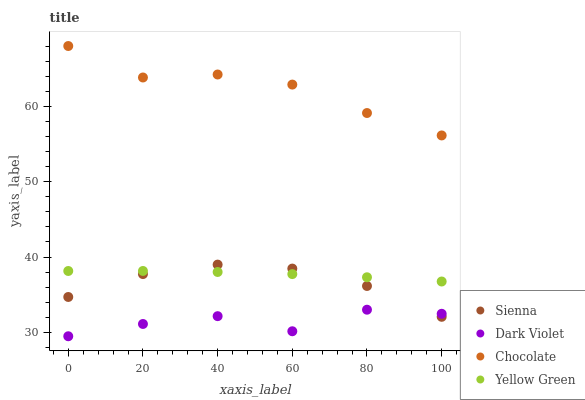Does Dark Violet have the minimum area under the curve?
Answer yes or no. Yes. Does Chocolate have the maximum area under the curve?
Answer yes or no. Yes. Does Yellow Green have the minimum area under the curve?
Answer yes or no. No. Does Yellow Green have the maximum area under the curve?
Answer yes or no. No. Is Yellow Green the smoothest?
Answer yes or no. Yes. Is Dark Violet the roughest?
Answer yes or no. Yes. Is Dark Violet the smoothest?
Answer yes or no. No. Is Yellow Green the roughest?
Answer yes or no. No. Does Dark Violet have the lowest value?
Answer yes or no. Yes. Does Yellow Green have the lowest value?
Answer yes or no. No. Does Chocolate have the highest value?
Answer yes or no. Yes. Does Yellow Green have the highest value?
Answer yes or no. No. Is Dark Violet less than Yellow Green?
Answer yes or no. Yes. Is Chocolate greater than Dark Violet?
Answer yes or no. Yes. Does Sienna intersect Dark Violet?
Answer yes or no. Yes. Is Sienna less than Dark Violet?
Answer yes or no. No. Is Sienna greater than Dark Violet?
Answer yes or no. No. Does Dark Violet intersect Yellow Green?
Answer yes or no. No. 